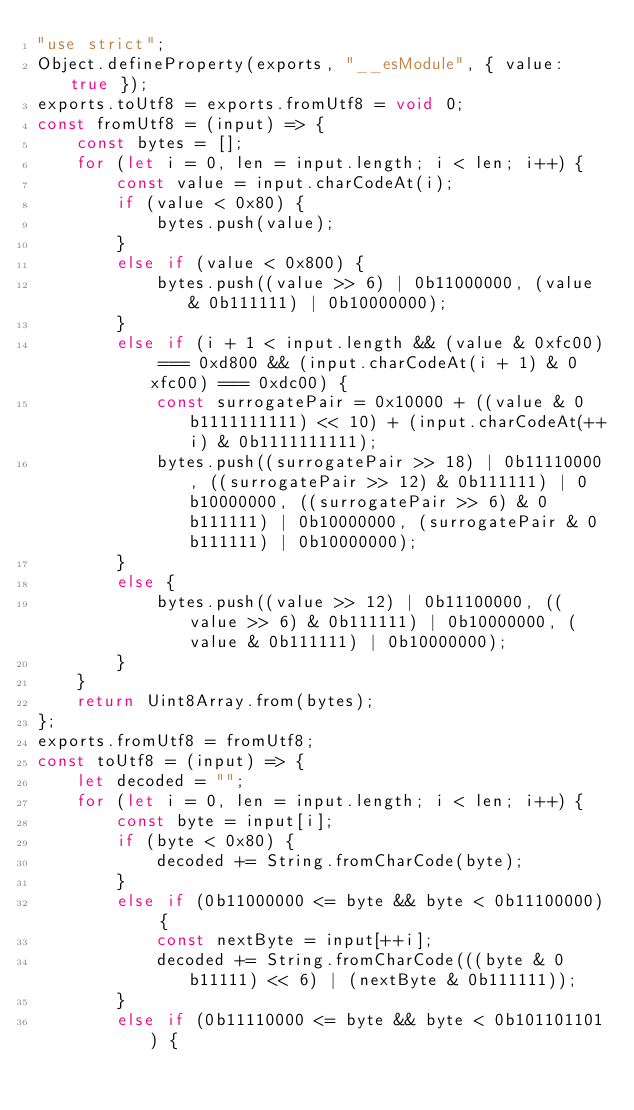<code> <loc_0><loc_0><loc_500><loc_500><_JavaScript_>"use strict";
Object.defineProperty(exports, "__esModule", { value: true });
exports.toUtf8 = exports.fromUtf8 = void 0;
const fromUtf8 = (input) => {
    const bytes = [];
    for (let i = 0, len = input.length; i < len; i++) {
        const value = input.charCodeAt(i);
        if (value < 0x80) {
            bytes.push(value);
        }
        else if (value < 0x800) {
            bytes.push((value >> 6) | 0b11000000, (value & 0b111111) | 0b10000000);
        }
        else if (i + 1 < input.length && (value & 0xfc00) === 0xd800 && (input.charCodeAt(i + 1) & 0xfc00) === 0xdc00) {
            const surrogatePair = 0x10000 + ((value & 0b1111111111) << 10) + (input.charCodeAt(++i) & 0b1111111111);
            bytes.push((surrogatePair >> 18) | 0b11110000, ((surrogatePair >> 12) & 0b111111) | 0b10000000, ((surrogatePair >> 6) & 0b111111) | 0b10000000, (surrogatePair & 0b111111) | 0b10000000);
        }
        else {
            bytes.push((value >> 12) | 0b11100000, ((value >> 6) & 0b111111) | 0b10000000, (value & 0b111111) | 0b10000000);
        }
    }
    return Uint8Array.from(bytes);
};
exports.fromUtf8 = fromUtf8;
const toUtf8 = (input) => {
    let decoded = "";
    for (let i = 0, len = input.length; i < len; i++) {
        const byte = input[i];
        if (byte < 0x80) {
            decoded += String.fromCharCode(byte);
        }
        else if (0b11000000 <= byte && byte < 0b11100000) {
            const nextByte = input[++i];
            decoded += String.fromCharCode(((byte & 0b11111) << 6) | (nextByte & 0b111111));
        }
        else if (0b11110000 <= byte && byte < 0b101101101) {</code> 